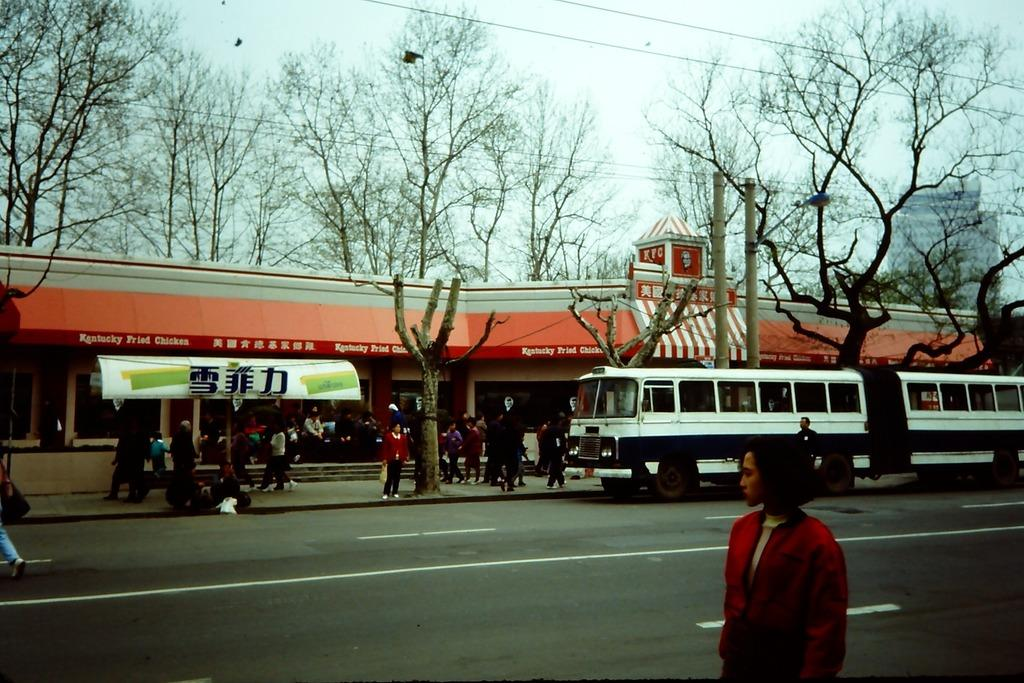What is happening in the image? There is a group of people standing in the image. What can be seen in the background of the image? There are buildings, a vehicle, trees, and the sky visible in the background of the image. What type of fan is being used by the person in the image? There is no fan present in the image. Why is the person in the image crying? There is no person crying in the image; it shows a group of people standing. 